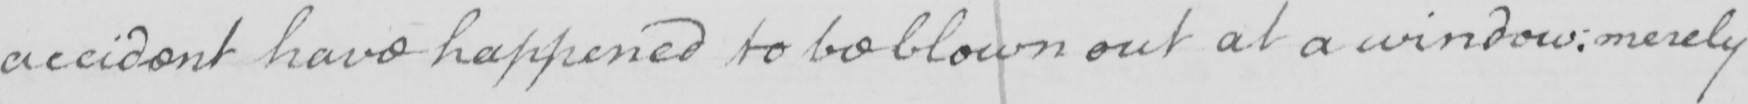Can you tell me what this handwritten text says? accident have happened to be blown out at a window :  merely 